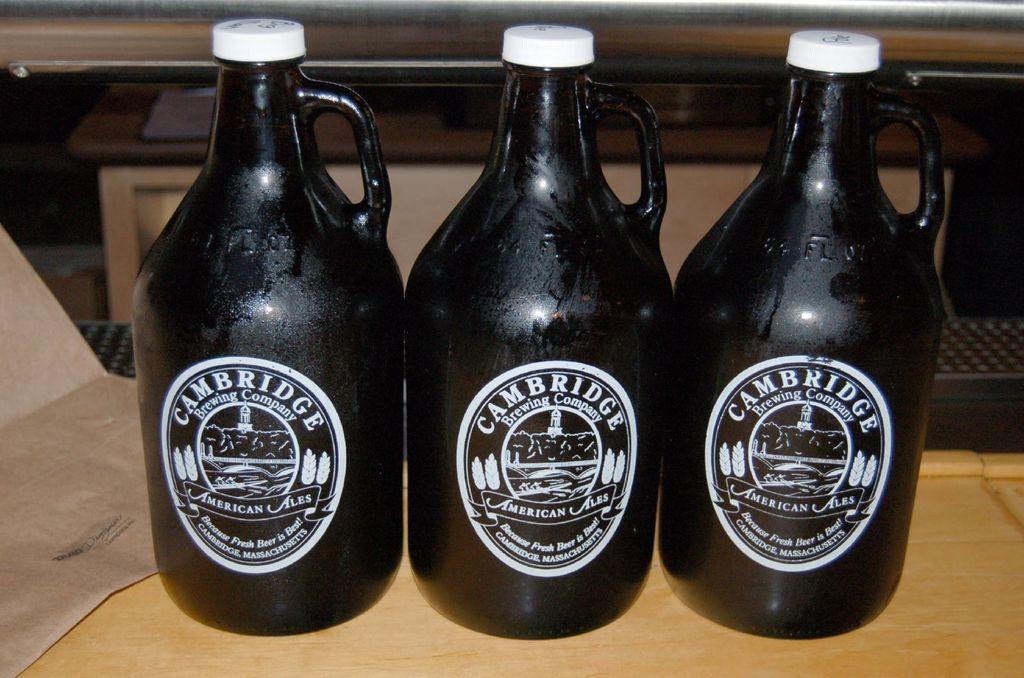What brand is seen here?
Your answer should be very brief. Cambridge.  where was this product manufactured?
Ensure brevity in your answer.  Cambridge. 